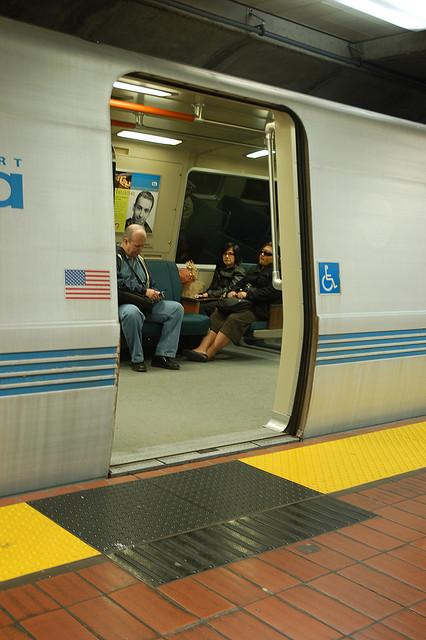What has the train indicated it is accessible to? Please explain your reasoning. wheelchairs. The area means it's usable through wheelchairs. 